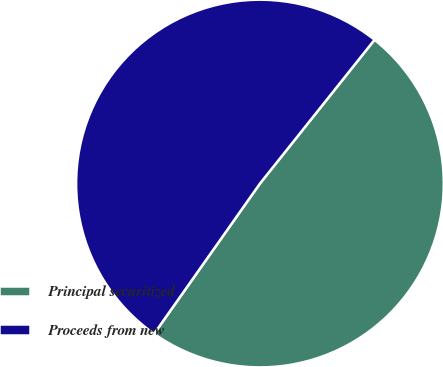<chart> <loc_0><loc_0><loc_500><loc_500><pie_chart><fcel>Principal securitized<fcel>Proceeds from new<nl><fcel>49.06%<fcel>50.94%<nl></chart> 